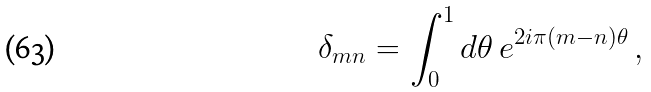<formula> <loc_0><loc_0><loc_500><loc_500>\delta _ { m n } = \int _ { 0 } ^ { 1 } d \theta \, e ^ { 2 i \pi ( m - n ) \theta } \, ,</formula> 